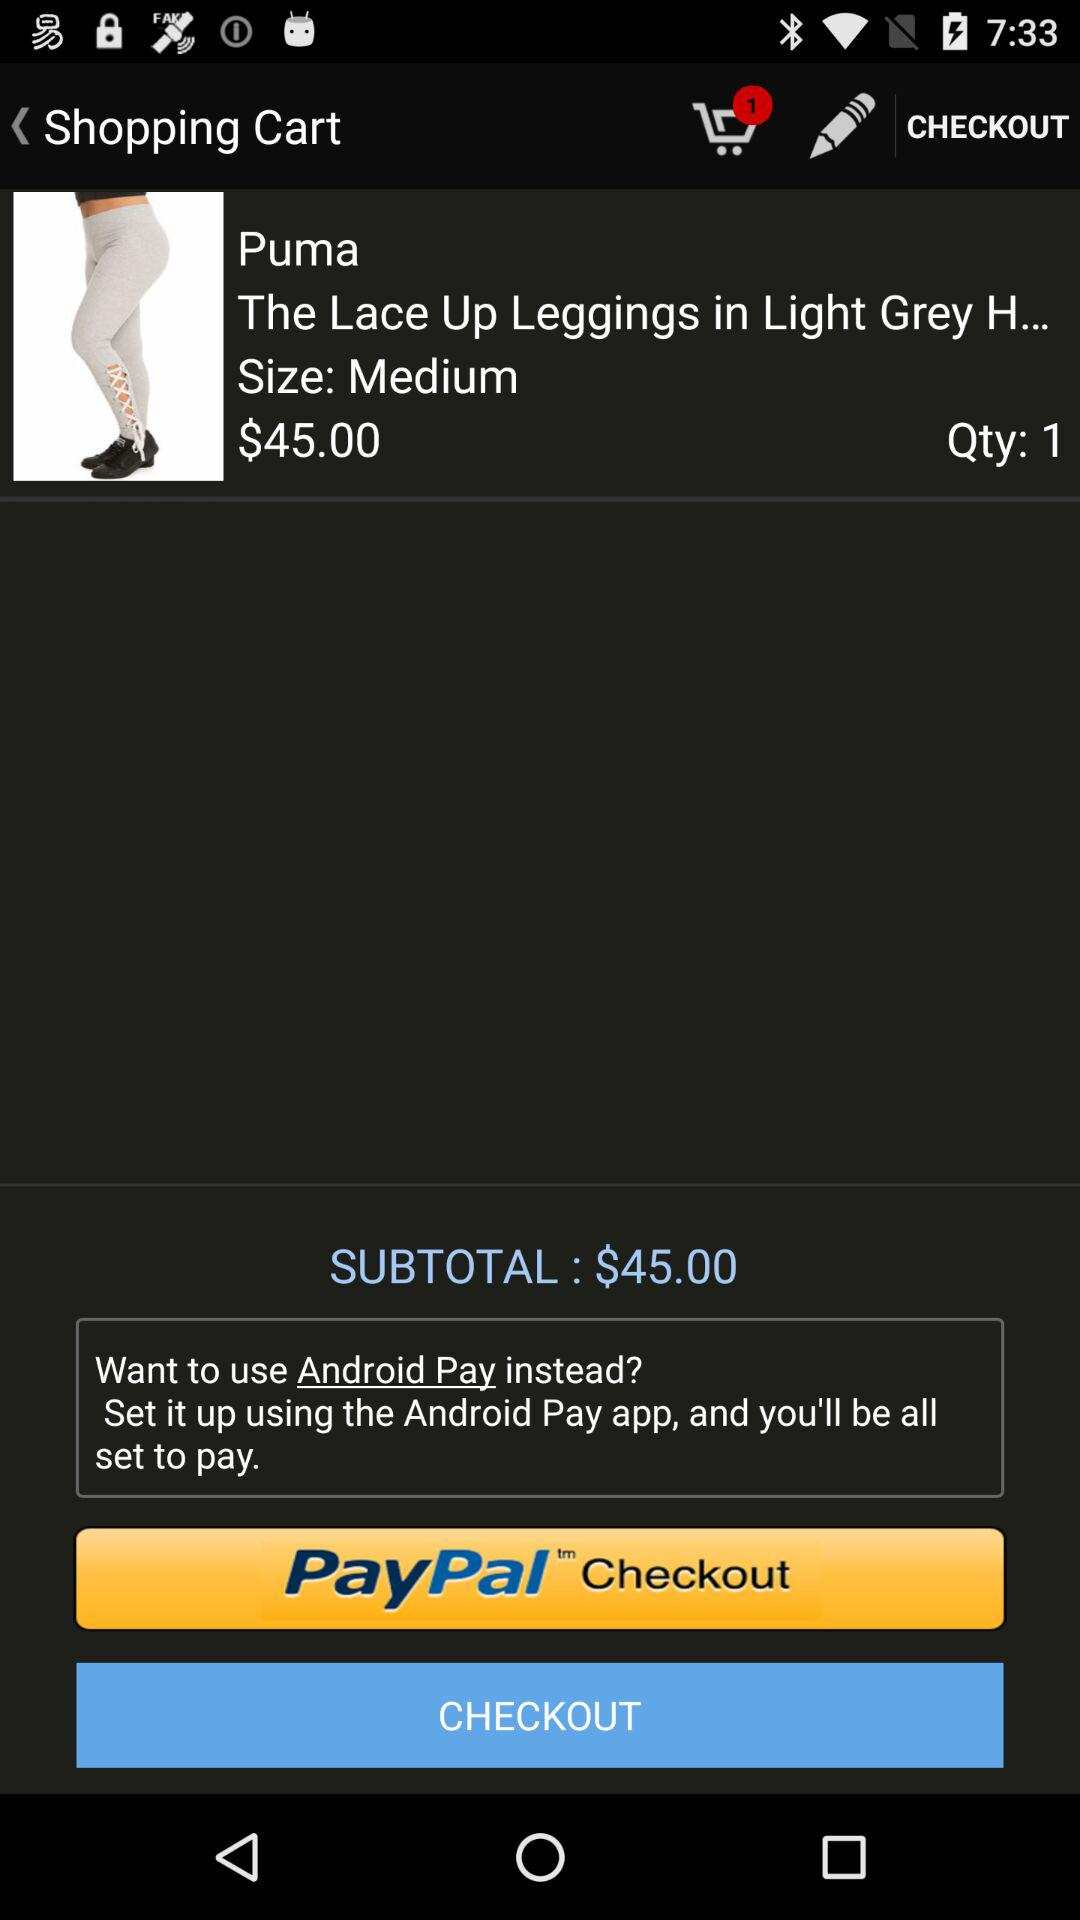How many items are in the shopping cart?
Answer the question using a single word or phrase. 1 